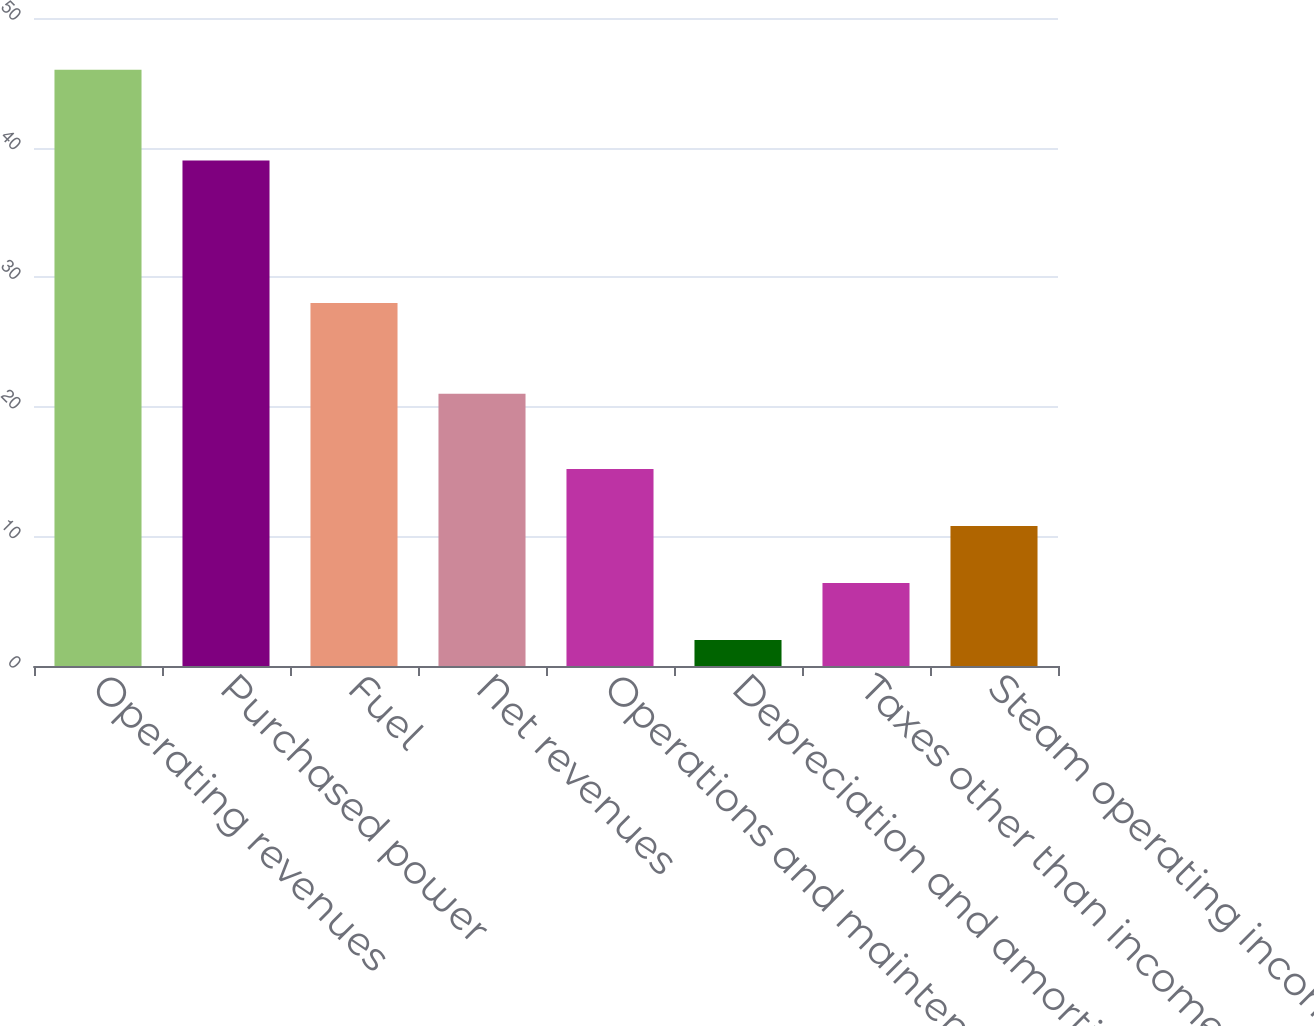Convert chart. <chart><loc_0><loc_0><loc_500><loc_500><bar_chart><fcel>Operating revenues<fcel>Purchased power<fcel>Fuel<fcel>Net revenues<fcel>Operations and maintenance<fcel>Depreciation and amortization<fcel>Taxes other than income taxes<fcel>Steam operating income<nl><fcel>46<fcel>39<fcel>28<fcel>21<fcel>15.2<fcel>2<fcel>6.4<fcel>10.8<nl></chart> 